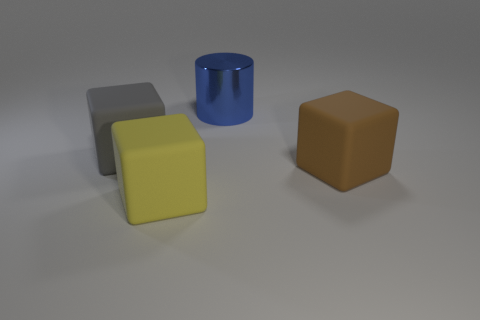Is there another object that has the same shape as the big gray rubber thing?
Provide a short and direct response. Yes. What is the shape of the large thing behind the block on the left side of the yellow thing?
Offer a very short reply. Cylinder. How many cubes are tiny cyan rubber things or large shiny objects?
Your answer should be very brief. 0. There is a object to the right of the large metal cylinder; is it the same shape as the large thing behind the large gray matte thing?
Provide a short and direct response. No. The big thing that is on the left side of the big blue cylinder and behind the brown cube is what color?
Ensure brevity in your answer.  Gray. How many other things are there of the same color as the big metallic object?
Provide a succinct answer. 0. There is a big yellow matte object; are there any rubber objects to the right of it?
Your answer should be very brief. Yes. Do the yellow matte block and the rubber object to the right of the big blue object have the same size?
Provide a short and direct response. Yes. How many other things are made of the same material as the big blue object?
Give a very brief answer. 0. What is the shape of the big object that is behind the brown cube and right of the big gray rubber cube?
Offer a very short reply. Cylinder. 